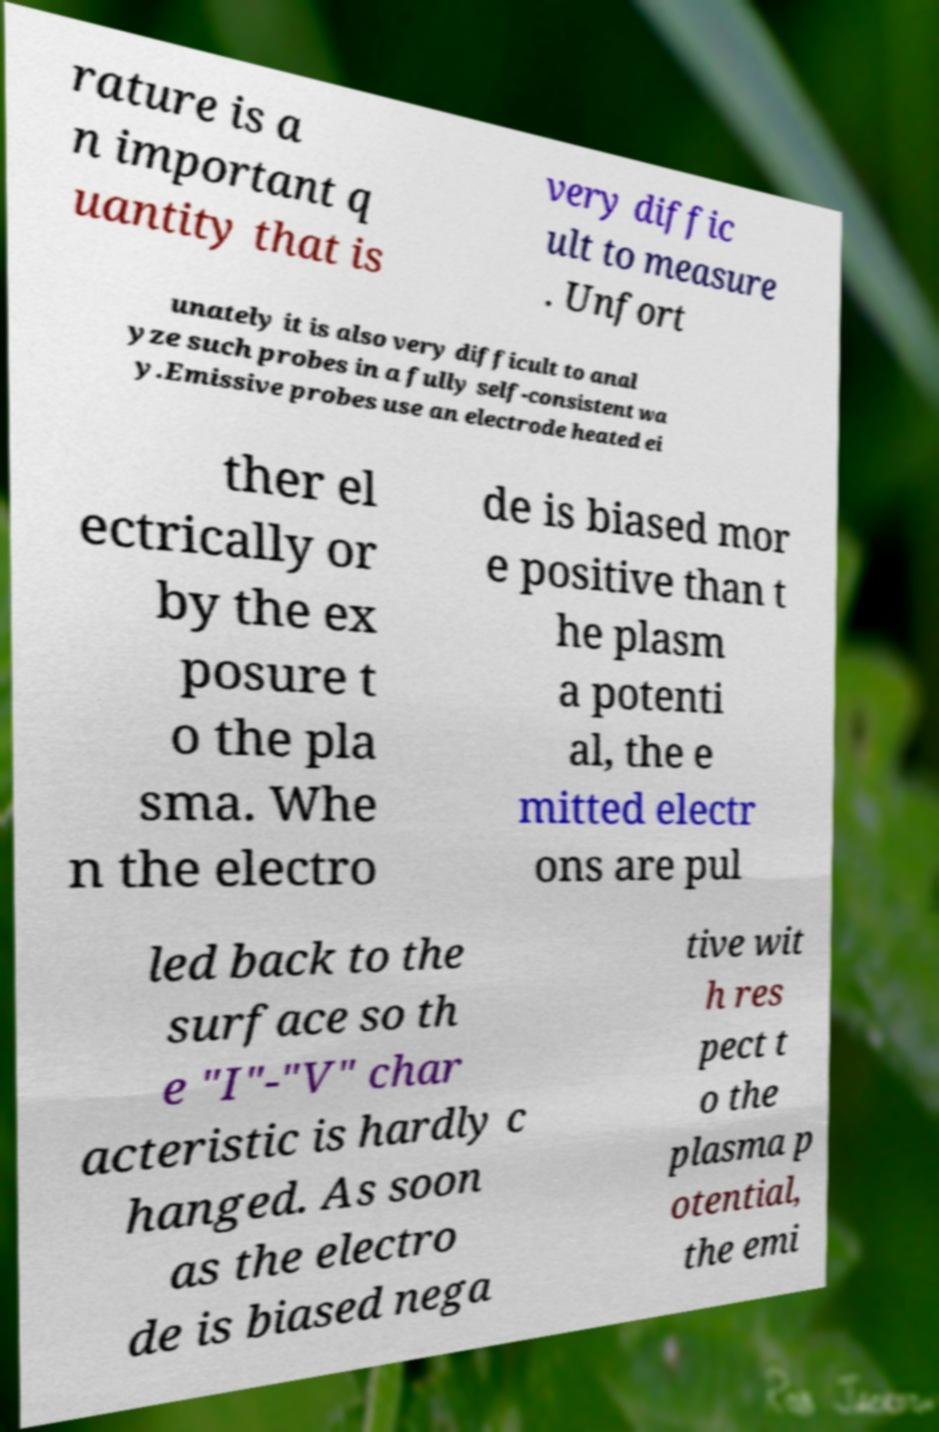Could you extract and type out the text from this image? rature is a n important q uantity that is very diffic ult to measure . Unfort unately it is also very difficult to anal yze such probes in a fully self-consistent wa y.Emissive probes use an electrode heated ei ther el ectrically or by the ex posure t o the pla sma. Whe n the electro de is biased mor e positive than t he plasm a potenti al, the e mitted electr ons are pul led back to the surface so th e "I"-"V" char acteristic is hardly c hanged. As soon as the electro de is biased nega tive wit h res pect t o the plasma p otential, the emi 